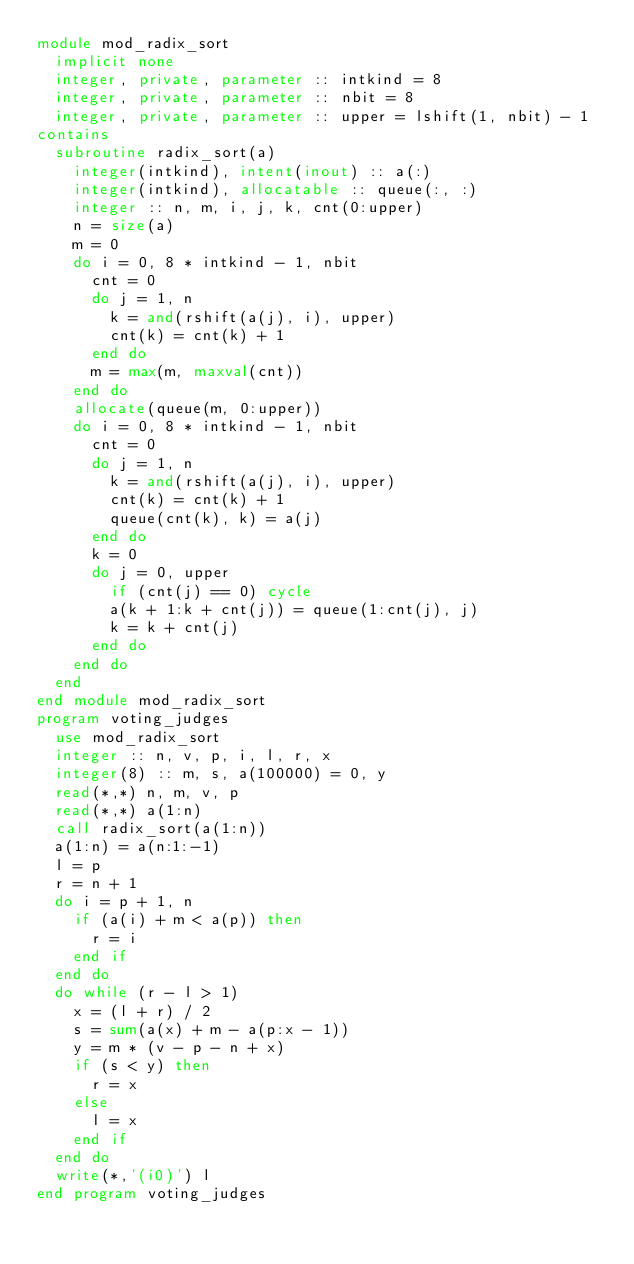Convert code to text. <code><loc_0><loc_0><loc_500><loc_500><_FORTRAN_>module mod_radix_sort
  implicit none
  integer, private, parameter :: intkind = 8
  integer, private, parameter :: nbit = 8
  integer, private, parameter :: upper = lshift(1, nbit) - 1
contains
  subroutine radix_sort(a)
    integer(intkind), intent(inout) :: a(:)
    integer(intkind), allocatable :: queue(:, :)
    integer :: n, m, i, j, k, cnt(0:upper)
    n = size(a)
    m = 0
    do i = 0, 8 * intkind - 1, nbit
      cnt = 0
      do j = 1, n
        k = and(rshift(a(j), i), upper)
        cnt(k) = cnt(k) + 1
      end do
      m = max(m, maxval(cnt))
    end do
    allocate(queue(m, 0:upper))
    do i = 0, 8 * intkind - 1, nbit
      cnt = 0
      do j = 1, n
        k = and(rshift(a(j), i), upper)
        cnt(k) = cnt(k) + 1
        queue(cnt(k), k) = a(j)
      end do
      k = 0
      do j = 0, upper
        if (cnt(j) == 0) cycle
        a(k + 1:k + cnt(j)) = queue(1:cnt(j), j)
        k = k + cnt(j)
      end do
    end do
  end
end module mod_radix_sort
program voting_judges
  use mod_radix_sort
  integer :: n, v, p, i, l, r, x
  integer(8) :: m, s, a(100000) = 0, y
  read(*,*) n, m, v, p
  read(*,*) a(1:n)
  call radix_sort(a(1:n))
  a(1:n) = a(n:1:-1)
  l = p
  r = n + 1
  do i = p + 1, n
    if (a(i) + m < a(p)) then
      r = i
    end if
  end do
  do while (r - l > 1)
    x = (l + r) / 2
    s = sum(a(x) + m - a(p:x - 1))
    y = m * (v - p - n + x)
    if (s < y) then
      r = x
    else
      l = x
    end if
  end do
  write(*,'(i0)') l
end program voting_judges</code> 